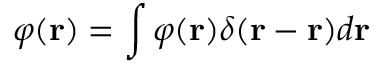<formula> <loc_0><loc_0><loc_500><loc_500>\varphi ( r ) = \int \varphi ( r ) \delta ( r - \acute { r } ) d \acute { r }</formula> 